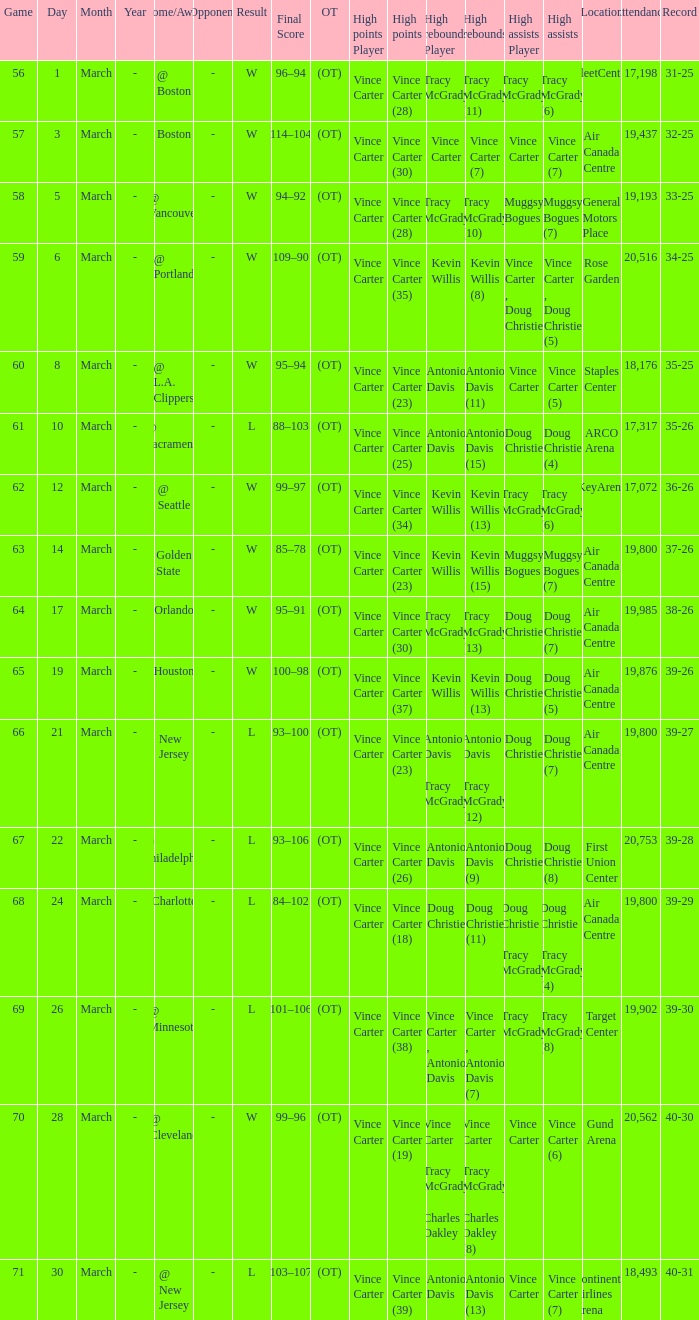Where did the team play and what was the attendance against new jersey? Air Canada Centre 19,800. 